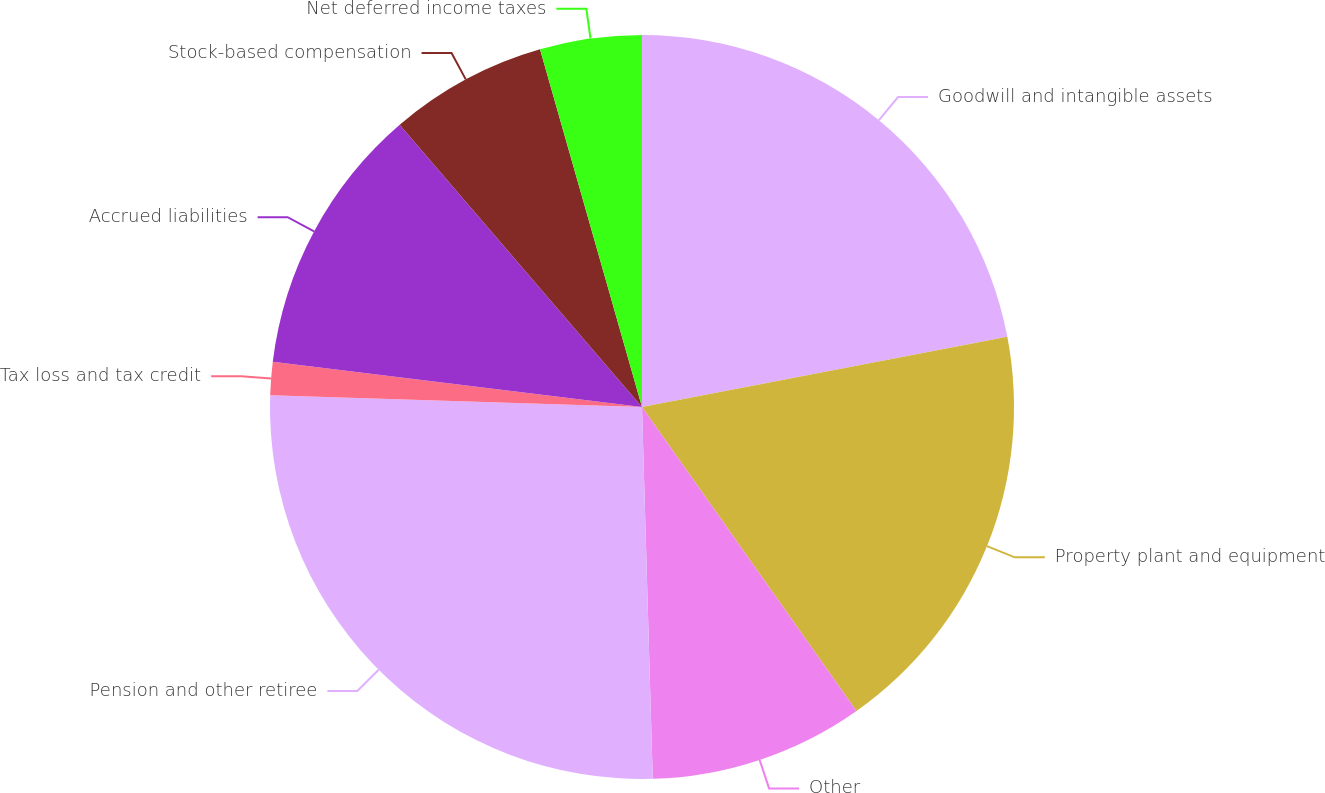Convert chart to OTSL. <chart><loc_0><loc_0><loc_500><loc_500><pie_chart><fcel>Goodwill and intangible assets<fcel>Property plant and equipment<fcel>Other<fcel>Pension and other retiree<fcel>Tax loss and tax credit<fcel>Accrued liabilities<fcel>Stock-based compensation<fcel>Net deferred income taxes<nl><fcel>21.98%<fcel>18.24%<fcel>9.32%<fcel>25.96%<fcel>1.44%<fcel>11.77%<fcel>6.87%<fcel>4.42%<nl></chart> 